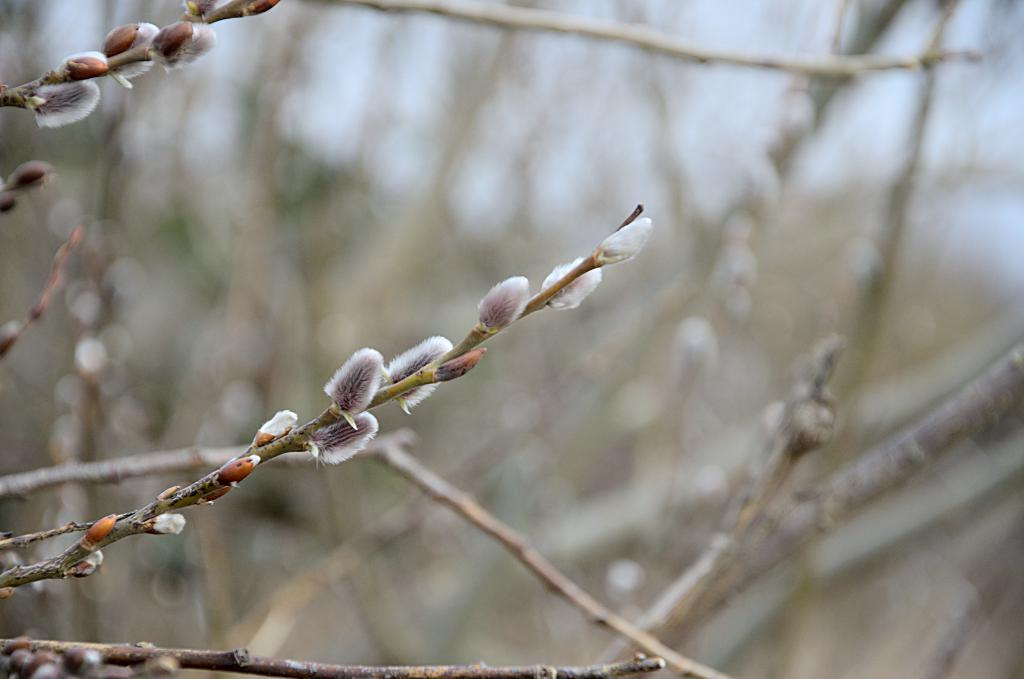What is visible in the foreground of the image? There are buds on a plant in the foreground of the image. How would you describe the background of the image? The background of the image is blurred. What type of organization is depicted in the image? There is no organization present in the image; it features a plant with buds in the foreground and a blurred background. 